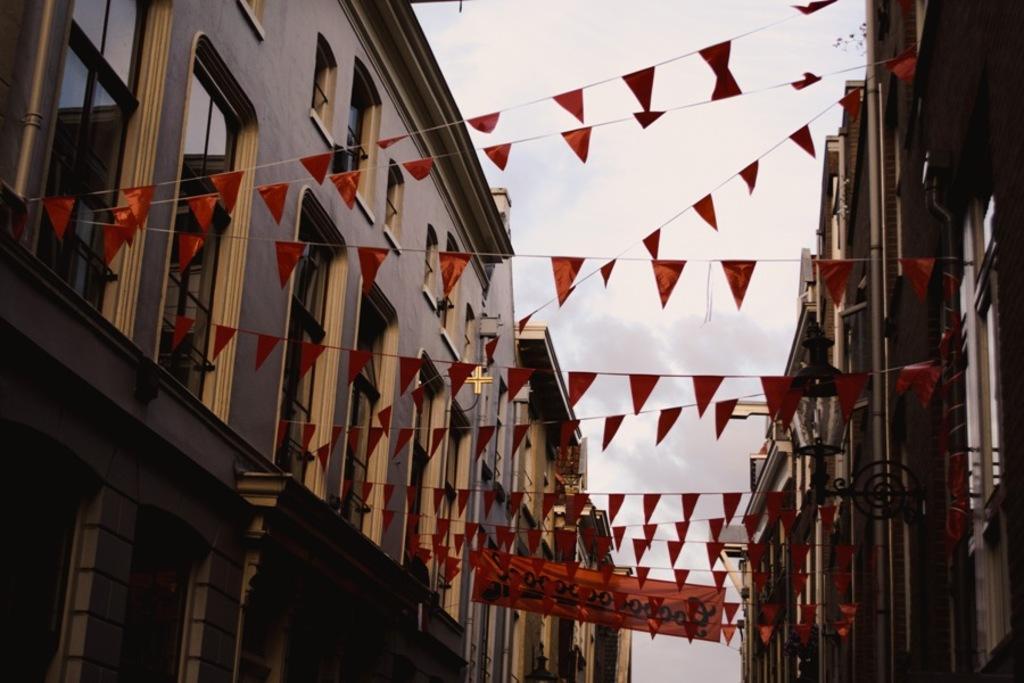Could you give a brief overview of what you see in this image? In this image we can see few buildings, flags, banner and a light attached to the building and there is a sky with clouds in the background. 